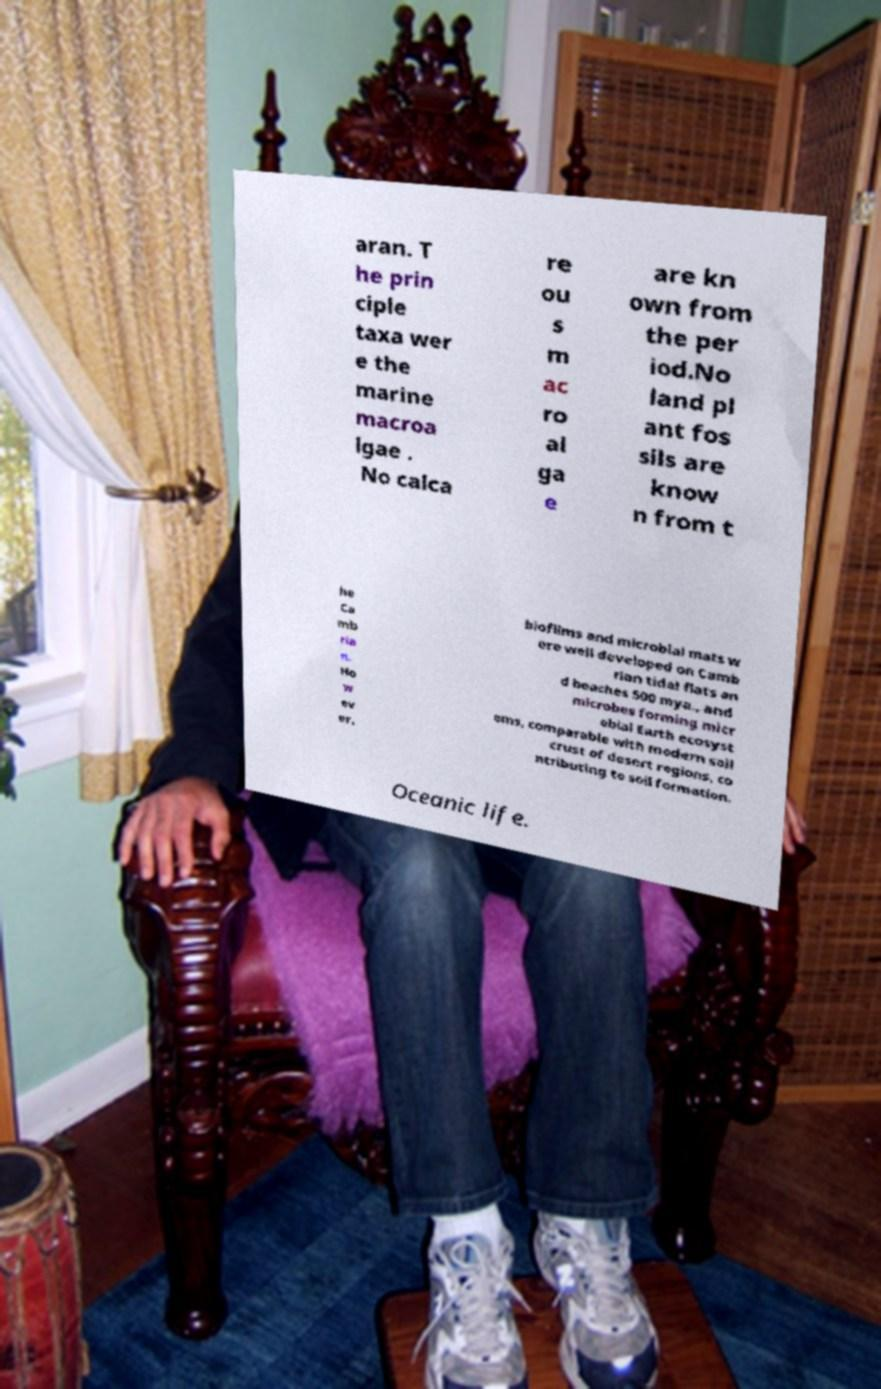Please read and relay the text visible in this image. What does it say? aran. T he prin ciple taxa wer e the marine macroa lgae . No calca re ou s m ac ro al ga e are kn own from the per iod.No land pl ant fos sils are know n from t he Ca mb ria n. Ho w ev er, biofilms and microbial mats w ere well developed on Camb rian tidal flats an d beaches 500 mya., and microbes forming micr obial Earth ecosyst ems, comparable with modern soil crust of desert regions, co ntributing to soil formation. Oceanic life. 